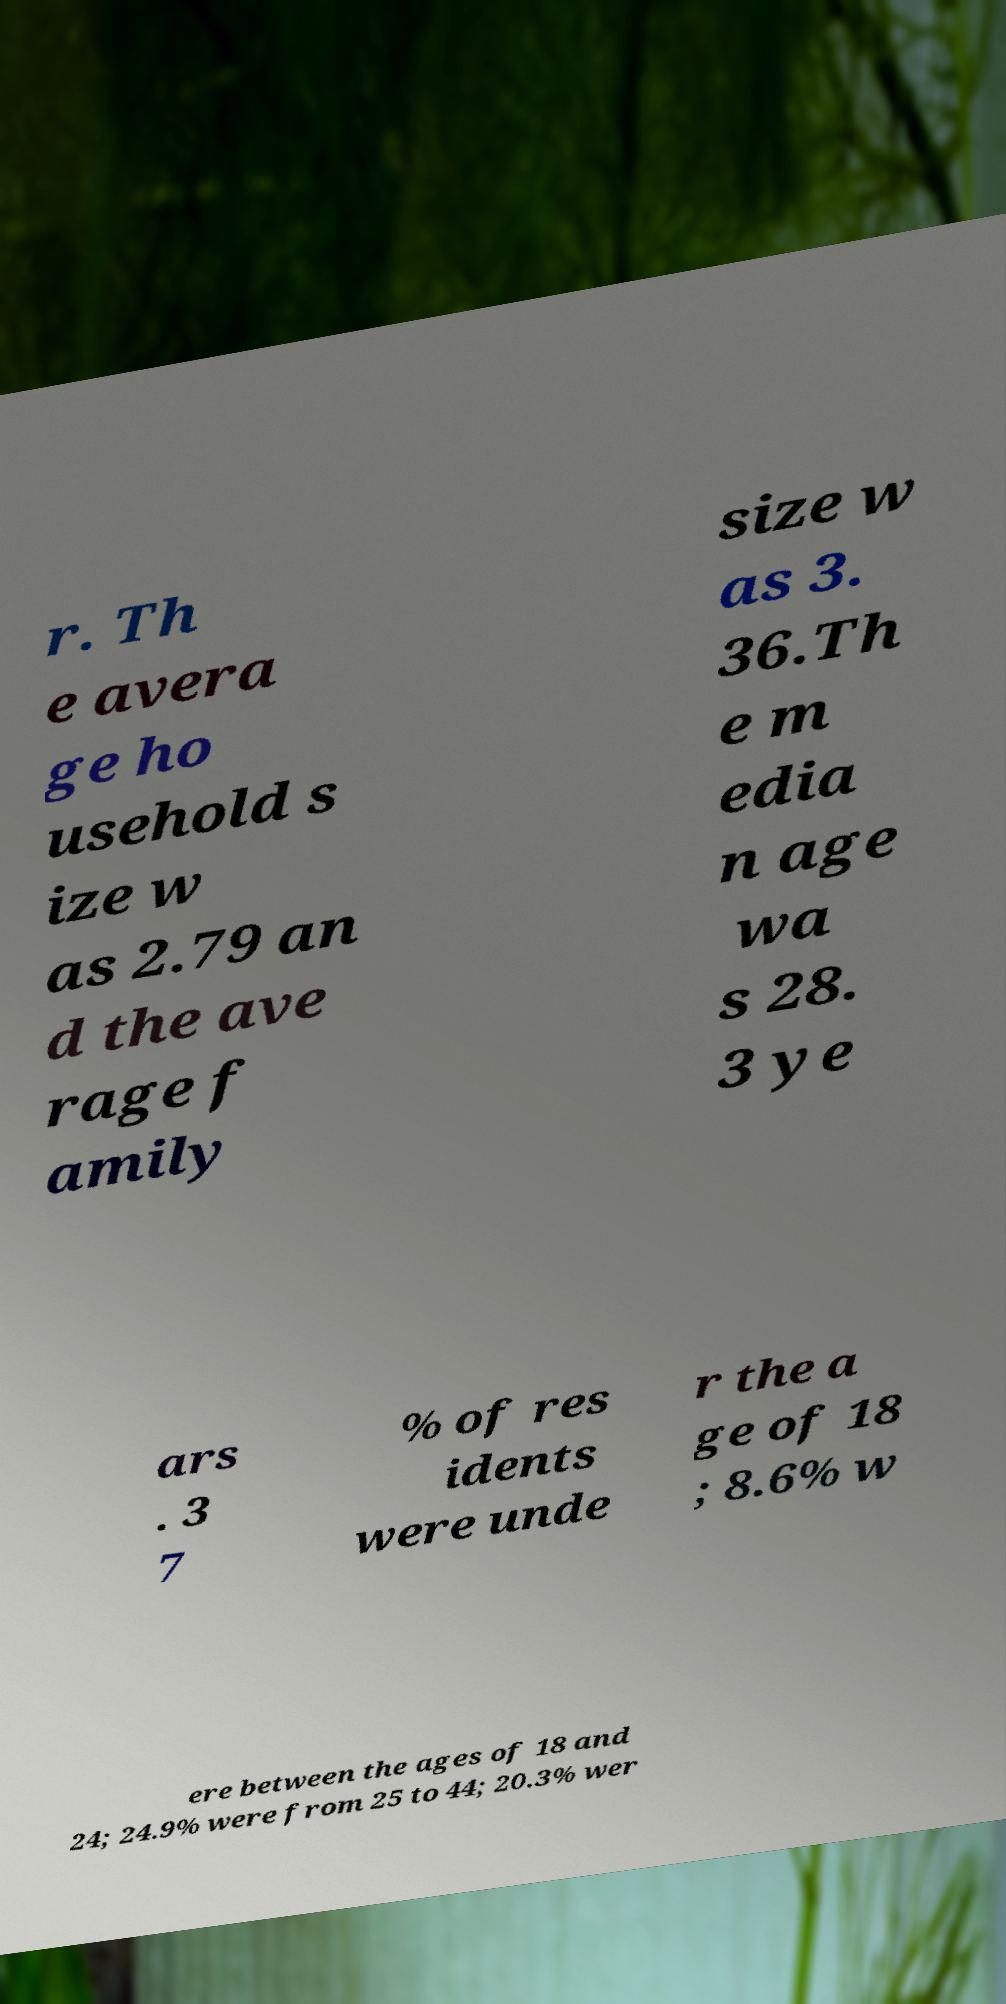Can you read and provide the text displayed in the image?This photo seems to have some interesting text. Can you extract and type it out for me? r. Th e avera ge ho usehold s ize w as 2.79 an d the ave rage f amily size w as 3. 36.Th e m edia n age wa s 28. 3 ye ars . 3 7 % of res idents were unde r the a ge of 18 ; 8.6% w ere between the ages of 18 and 24; 24.9% were from 25 to 44; 20.3% wer 